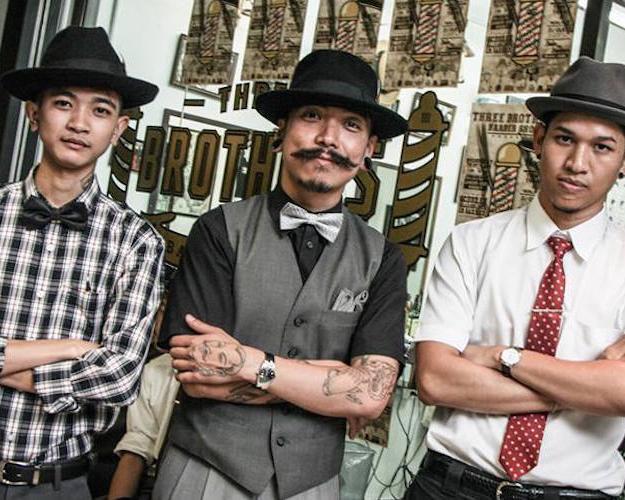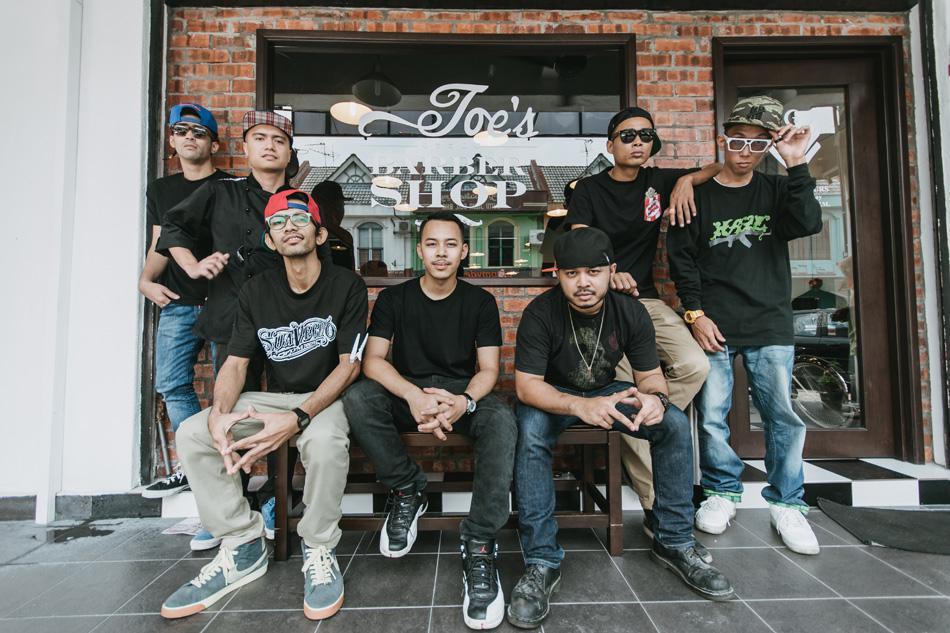The first image is the image on the left, the second image is the image on the right. Evaluate the accuracy of this statement regarding the images: "There is exactly one person wearing a vest.". Is it true? Answer yes or no. Yes. The first image is the image on the left, the second image is the image on the right. For the images shown, is this caption "There is a single man in a barbershop chair with at least one other man next to him with no sissors." true? Answer yes or no. No. 